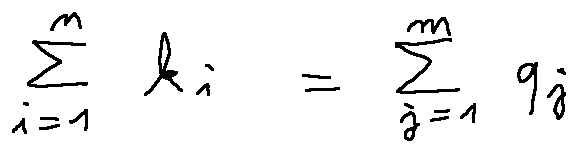<formula> <loc_0><loc_0><loc_500><loc_500>\sum \lim i t s _ { i = 1 } ^ { n } k _ { i } = \sum \lim i t s _ { j = 1 } ^ { m } q _ { j }</formula> 